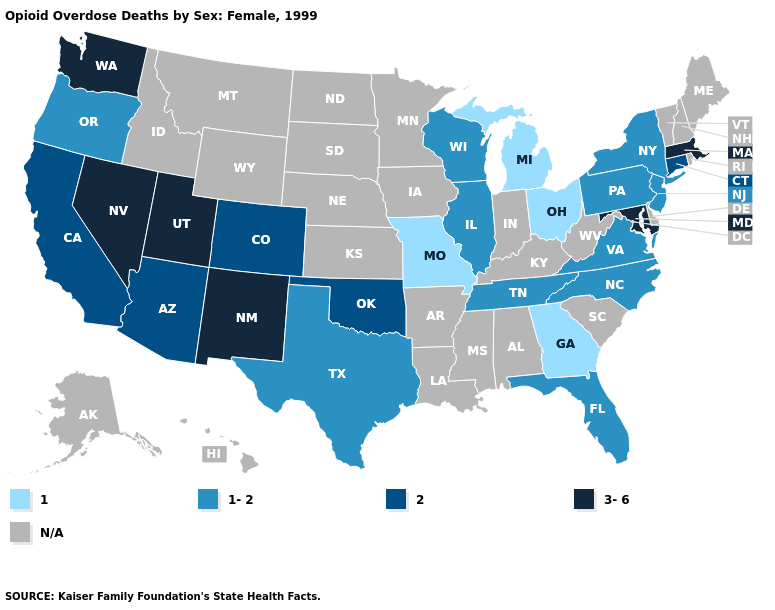What is the value of Wyoming?
Answer briefly. N/A. Which states have the lowest value in the USA?
Write a very short answer. Georgia, Michigan, Missouri, Ohio. Name the states that have a value in the range 1-2?
Keep it brief. Florida, Illinois, New Jersey, New York, North Carolina, Oregon, Pennsylvania, Tennessee, Texas, Virginia, Wisconsin. Which states have the lowest value in the West?
Short answer required. Oregon. Which states have the lowest value in the USA?
Concise answer only. Georgia, Michigan, Missouri, Ohio. Name the states that have a value in the range 1?
Short answer required. Georgia, Michigan, Missouri, Ohio. What is the highest value in the USA?
Concise answer only. 3-6. What is the highest value in the Northeast ?
Quick response, please. 3-6. Name the states that have a value in the range 3-6?
Keep it brief. Maryland, Massachusetts, Nevada, New Mexico, Utah, Washington. Is the legend a continuous bar?
Concise answer only. No. Is the legend a continuous bar?
Short answer required. No. Which states have the lowest value in the MidWest?
Give a very brief answer. Michigan, Missouri, Ohio. Does California have the lowest value in the West?
Give a very brief answer. No. Name the states that have a value in the range 2?
Concise answer only. Arizona, California, Colorado, Connecticut, Oklahoma. 